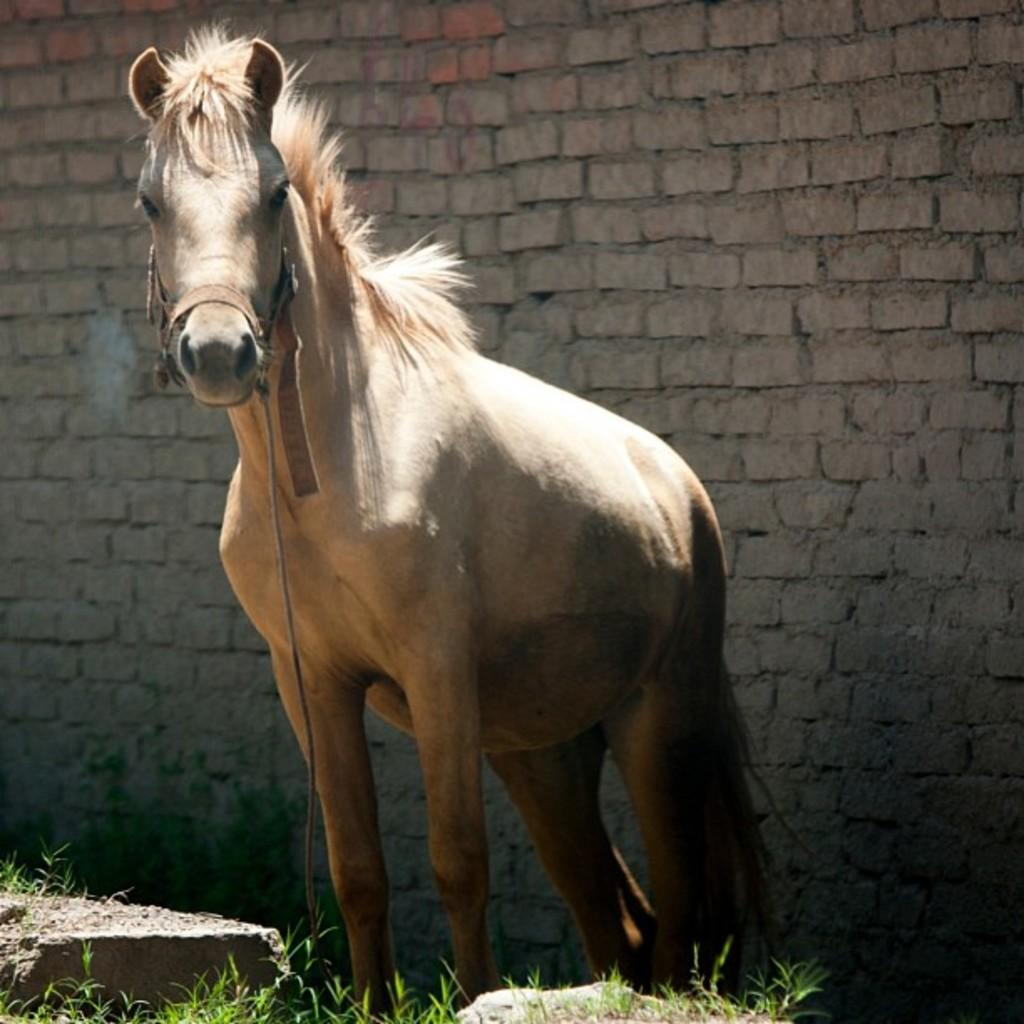What animal is present in the picture? There is a horse in the picture. What type of terrain is visible in the picture? There is grass on the ground in the picture. What can be seen in the background of the picture? There is a wall in the background of the picture. How many snails are crawling on the horse in the picture? There are no snails present in the picture; it only features a horse, grass, and a wall in the background. 